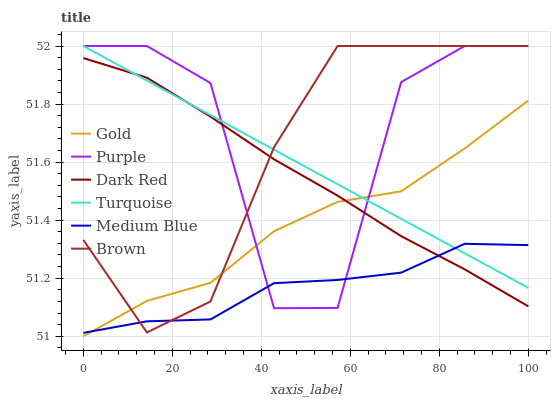Does Turquoise have the minimum area under the curve?
Answer yes or no. No. Does Turquoise have the maximum area under the curve?
Answer yes or no. No. Is Gold the smoothest?
Answer yes or no. No. Is Gold the roughest?
Answer yes or no. No. Does Turquoise have the lowest value?
Answer yes or no. No. Does Gold have the highest value?
Answer yes or no. No. 